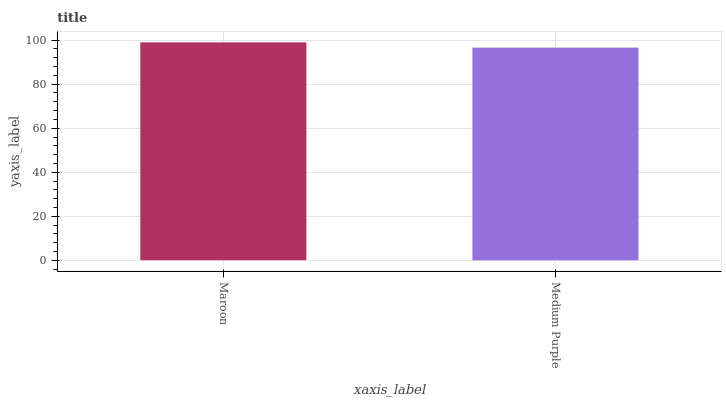Is Medium Purple the minimum?
Answer yes or no. Yes. Is Maroon the maximum?
Answer yes or no. Yes. Is Medium Purple the maximum?
Answer yes or no. No. Is Maroon greater than Medium Purple?
Answer yes or no. Yes. Is Medium Purple less than Maroon?
Answer yes or no. Yes. Is Medium Purple greater than Maroon?
Answer yes or no. No. Is Maroon less than Medium Purple?
Answer yes or no. No. Is Maroon the high median?
Answer yes or no. Yes. Is Medium Purple the low median?
Answer yes or no. Yes. Is Medium Purple the high median?
Answer yes or no. No. Is Maroon the low median?
Answer yes or no. No. 